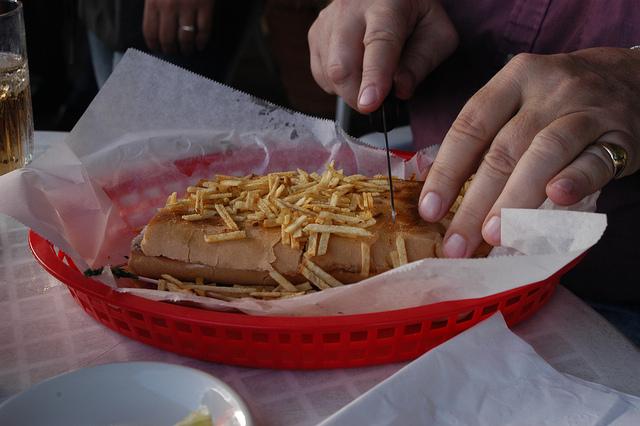Is this a Japanese restaurant?
Keep it brief. No. What is the on the person's finger?
Short answer required. Ring. Is the white container biodegradable?
Keep it brief. No. Why is the food not on a plate?
Be succinct. In basket. Is this a meal for one person?
Be succinct. Yes. What are the hands about to do?
Answer briefly. Cut. How many sandwiches do you see?
Be succinct. 1. What color is the checkered wrapper?
Write a very short answer. White. What food is on the tray?
Write a very short answer. Sandwich. What colors are the napkins?
Be succinct. White. 